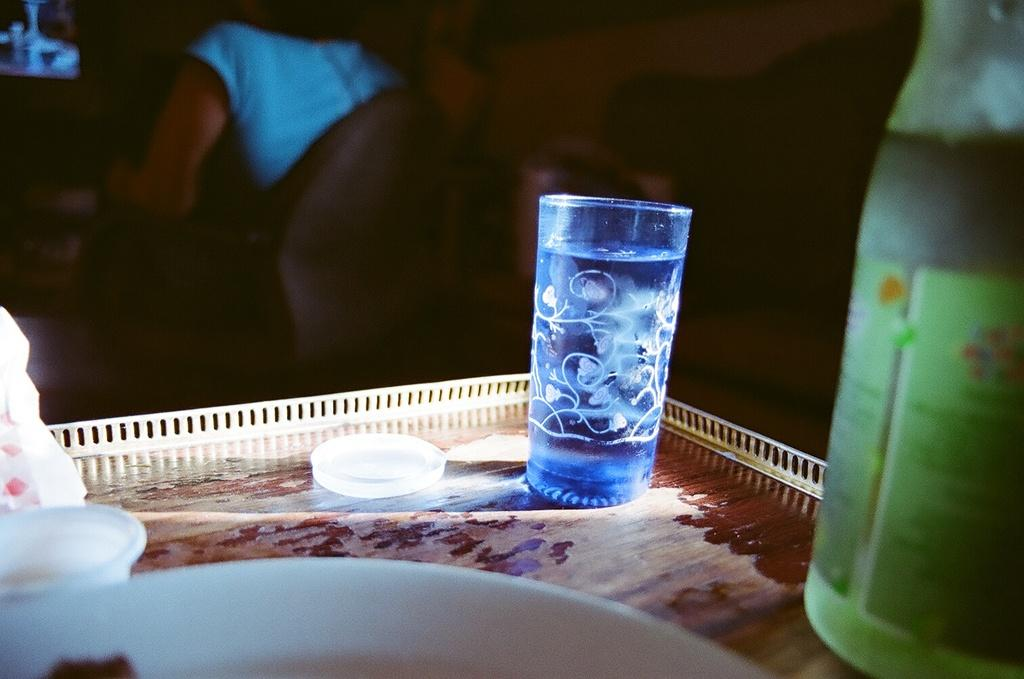What object is present in the image that can hold multiple items? There is a tray in the image that can hold multiple items. What is placed on the tray? There is a glass and a wine bottle on the tray. Can you describe the glass on the tray? The glass on the tray is likely used for holding a beverage. What type of beverage might be associated with the wine bottle on the tray? The wine bottle on the tray suggests that wine might be the associated beverage. How many socks are visible on the tray in the image? There are no socks visible on the tray in the image. What time of day is represented by the hour on the tray? There is no hour present on the tray in the image. 